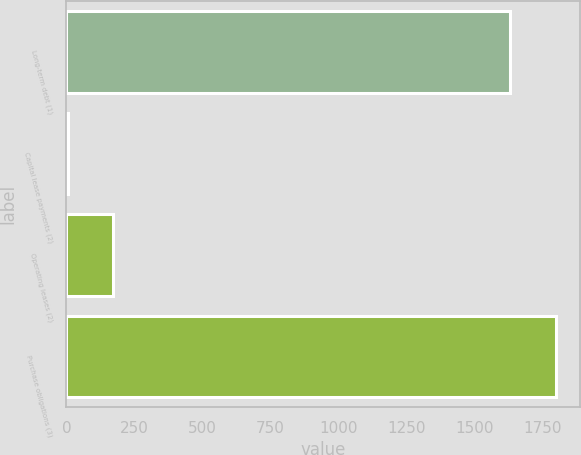<chart> <loc_0><loc_0><loc_500><loc_500><bar_chart><fcel>Long-term debt (1)<fcel>Capital lease payments (2)<fcel>Operating leases (2)<fcel>Purchase obligations (3)<nl><fcel>1631<fcel>4<fcel>172.5<fcel>1799.5<nl></chart> 